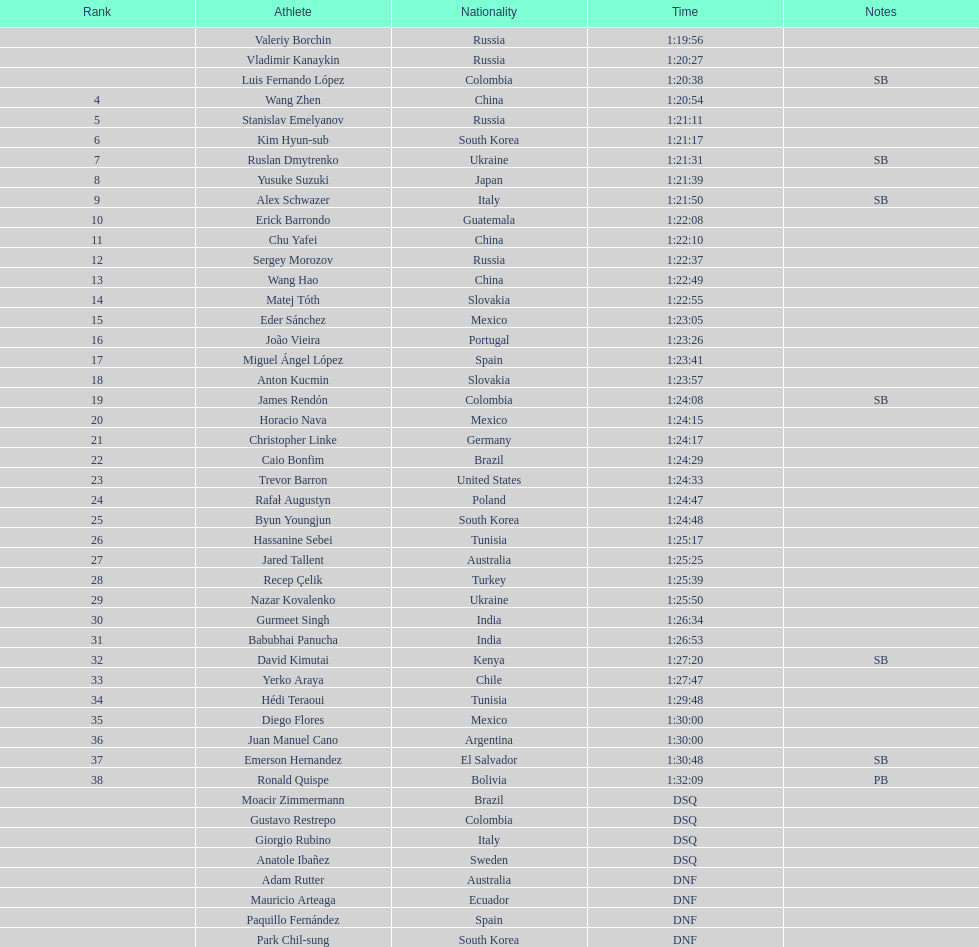How many japanese individuals are in the top 10? 1. Give me the full table as a dictionary. {'header': ['Rank', 'Athlete', 'Nationality', 'Time', 'Notes'], 'rows': [['', 'Valeriy Borchin', 'Russia', '1:19:56', ''], ['', 'Vladimir Kanaykin', 'Russia', '1:20:27', ''], ['', 'Luis Fernando López', 'Colombia', '1:20:38', 'SB'], ['4', 'Wang Zhen', 'China', '1:20:54', ''], ['5', 'Stanislav Emelyanov', 'Russia', '1:21:11', ''], ['6', 'Kim Hyun-sub', 'South Korea', '1:21:17', ''], ['7', 'Ruslan Dmytrenko', 'Ukraine', '1:21:31', 'SB'], ['8', 'Yusuke Suzuki', 'Japan', '1:21:39', ''], ['9', 'Alex Schwazer', 'Italy', '1:21:50', 'SB'], ['10', 'Erick Barrondo', 'Guatemala', '1:22:08', ''], ['11', 'Chu Yafei', 'China', '1:22:10', ''], ['12', 'Sergey Morozov', 'Russia', '1:22:37', ''], ['13', 'Wang Hao', 'China', '1:22:49', ''], ['14', 'Matej Tóth', 'Slovakia', '1:22:55', ''], ['15', 'Eder Sánchez', 'Mexico', '1:23:05', ''], ['16', 'João Vieira', 'Portugal', '1:23:26', ''], ['17', 'Miguel Ángel López', 'Spain', '1:23:41', ''], ['18', 'Anton Kucmin', 'Slovakia', '1:23:57', ''], ['19', 'James Rendón', 'Colombia', '1:24:08', 'SB'], ['20', 'Horacio Nava', 'Mexico', '1:24:15', ''], ['21', 'Christopher Linke', 'Germany', '1:24:17', ''], ['22', 'Caio Bonfim', 'Brazil', '1:24:29', ''], ['23', 'Trevor Barron', 'United States', '1:24:33', ''], ['24', 'Rafał Augustyn', 'Poland', '1:24:47', ''], ['25', 'Byun Youngjun', 'South Korea', '1:24:48', ''], ['26', 'Hassanine Sebei', 'Tunisia', '1:25:17', ''], ['27', 'Jared Tallent', 'Australia', '1:25:25', ''], ['28', 'Recep Çelik', 'Turkey', '1:25:39', ''], ['29', 'Nazar Kovalenko', 'Ukraine', '1:25:50', ''], ['30', 'Gurmeet Singh', 'India', '1:26:34', ''], ['31', 'Babubhai Panucha', 'India', '1:26:53', ''], ['32', 'David Kimutai', 'Kenya', '1:27:20', 'SB'], ['33', 'Yerko Araya', 'Chile', '1:27:47', ''], ['34', 'Hédi Teraoui', 'Tunisia', '1:29:48', ''], ['35', 'Diego Flores', 'Mexico', '1:30:00', ''], ['36', 'Juan Manuel Cano', 'Argentina', '1:30:00', ''], ['37', 'Emerson Hernandez', 'El Salvador', '1:30:48', 'SB'], ['38', 'Ronald Quispe', 'Bolivia', '1:32:09', 'PB'], ['', 'Moacir Zimmermann', 'Brazil', 'DSQ', ''], ['', 'Gustavo Restrepo', 'Colombia', 'DSQ', ''], ['', 'Giorgio Rubino', 'Italy', 'DSQ', ''], ['', 'Anatole Ibañez', 'Sweden', 'DSQ', ''], ['', 'Adam Rutter', 'Australia', 'DNF', ''], ['', 'Mauricio Arteaga', 'Ecuador', 'DNF', ''], ['', 'Paquillo Fernández', 'Spain', 'DNF', ''], ['', 'Park Chil-sung', 'South Korea', 'DNF', '']]} 